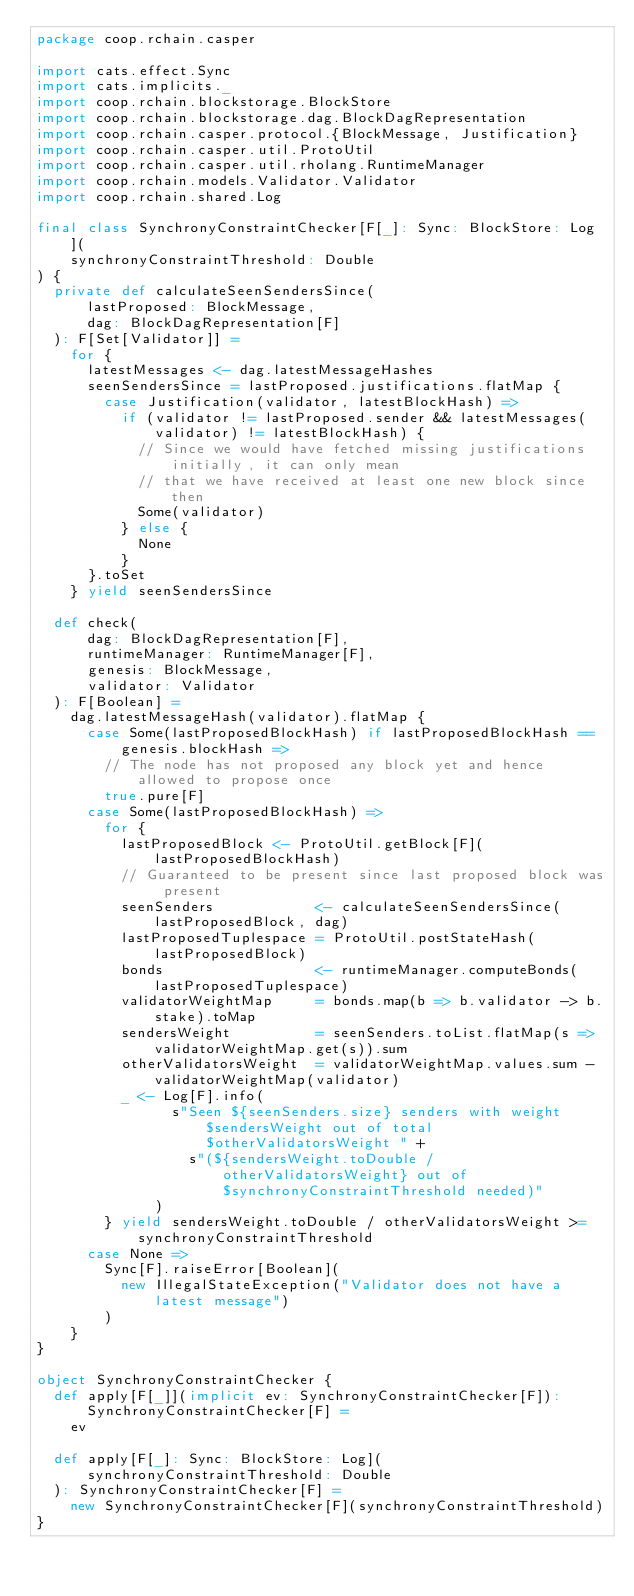Convert code to text. <code><loc_0><loc_0><loc_500><loc_500><_Scala_>package coop.rchain.casper

import cats.effect.Sync
import cats.implicits._
import coop.rchain.blockstorage.BlockStore
import coop.rchain.blockstorage.dag.BlockDagRepresentation
import coop.rchain.casper.protocol.{BlockMessage, Justification}
import coop.rchain.casper.util.ProtoUtil
import coop.rchain.casper.util.rholang.RuntimeManager
import coop.rchain.models.Validator.Validator
import coop.rchain.shared.Log

final class SynchronyConstraintChecker[F[_]: Sync: BlockStore: Log](
    synchronyConstraintThreshold: Double
) {
  private def calculateSeenSendersSince(
      lastProposed: BlockMessage,
      dag: BlockDagRepresentation[F]
  ): F[Set[Validator]] =
    for {
      latestMessages <- dag.latestMessageHashes
      seenSendersSince = lastProposed.justifications.flatMap {
        case Justification(validator, latestBlockHash) =>
          if (validator != lastProposed.sender && latestMessages(validator) != latestBlockHash) {
            // Since we would have fetched missing justifications initially, it can only mean
            // that we have received at least one new block since then
            Some(validator)
          } else {
            None
          }
      }.toSet
    } yield seenSendersSince

  def check(
      dag: BlockDagRepresentation[F],
      runtimeManager: RuntimeManager[F],
      genesis: BlockMessage,
      validator: Validator
  ): F[Boolean] =
    dag.latestMessageHash(validator).flatMap {
      case Some(lastProposedBlockHash) if lastProposedBlockHash == genesis.blockHash =>
        // The node has not proposed any block yet and hence allowed to propose once
        true.pure[F]
      case Some(lastProposedBlockHash) =>
        for {
          lastProposedBlock <- ProtoUtil.getBlock[F](lastProposedBlockHash)
          // Guaranteed to be present since last proposed block was present
          seenSenders            <- calculateSeenSendersSince(lastProposedBlock, dag)
          lastProposedTuplespace = ProtoUtil.postStateHash(lastProposedBlock)
          bonds                  <- runtimeManager.computeBonds(lastProposedTuplespace)
          validatorWeightMap     = bonds.map(b => b.validator -> b.stake).toMap
          sendersWeight          = seenSenders.toList.flatMap(s => validatorWeightMap.get(s)).sum
          otherValidatorsWeight  = validatorWeightMap.values.sum - validatorWeightMap(validator)
          _ <- Log[F].info(
                s"Seen ${seenSenders.size} senders with weight $sendersWeight out of total $otherValidatorsWeight " +
                  s"(${sendersWeight.toDouble / otherValidatorsWeight} out of $synchronyConstraintThreshold needed)"
              )
        } yield sendersWeight.toDouble / otherValidatorsWeight >= synchronyConstraintThreshold
      case None =>
        Sync[F].raiseError[Boolean](
          new IllegalStateException("Validator does not have a latest message")
        )
    }
}

object SynchronyConstraintChecker {
  def apply[F[_]](implicit ev: SynchronyConstraintChecker[F]): SynchronyConstraintChecker[F] =
    ev

  def apply[F[_]: Sync: BlockStore: Log](
      synchronyConstraintThreshold: Double
  ): SynchronyConstraintChecker[F] =
    new SynchronyConstraintChecker[F](synchronyConstraintThreshold)
}
</code> 